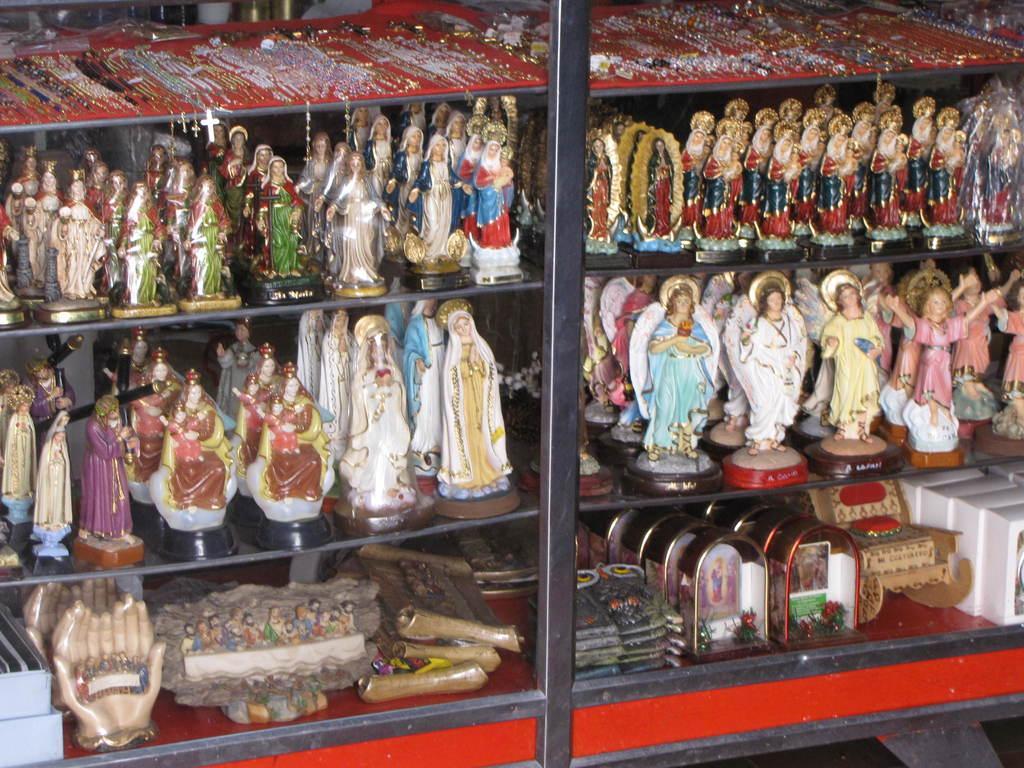How would you summarize this image in a sentence or two? In the picture I can see dolls on the shelf. 